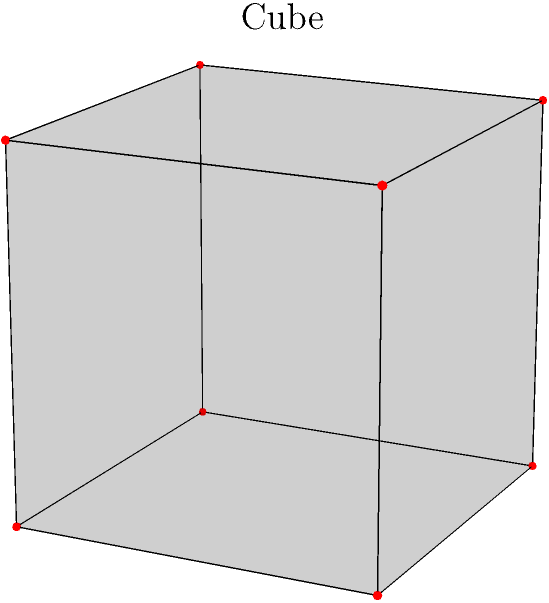Consider the cube shown in the figure. Given that it has 8 vertices and 12 edges, calculate the Euler characteristic of this polyhedron and determine the number of faces it has. How does this relate to the general formula for the Euler characteristic of a polyhedron? To solve this problem, we'll use the Euler characteristic formula and follow these steps:

1) The Euler characteristic ($\chi$) for a polyhedron is given by the formula:

   $$\chi = V - E + F$$

   where $V$ is the number of vertices, $E$ is the number of edges, and $F$ is the number of faces.

2) We are given that:
   - Number of vertices, $V = 8$
   - Number of edges, $E = 12$

3) For a simple polyhedron like a cube, we know that the Euler characteristic should be 2. So:

   $$2 = 8 - 12 + F$$

4) Solving for $F$:
   
   $$F = 2 - 8 + 12 = 6$$

5) We can verify this result by visualizing the cube: it indeed has 6 faces (top, bottom, front, back, left, and right).

6) This result confirms the general Euler characteristic formula for convex polyhedra:

   $$V - E + F = 2$$

This formula holds true for all simple polyhedra that are topologically equivalent to a sphere (i.e., they can be deformed into a sphere without tearing or gluing).

The Euler characteristic is a topological invariant, meaning it doesn't change under continuous deformations of the shape. This property makes it a powerful tool in topology and other areas of mathematics and physics, including your field of acoustics and signal processing where topological data analysis might be applied.
Answer: Euler characteristic: 2; Number of faces: 6 